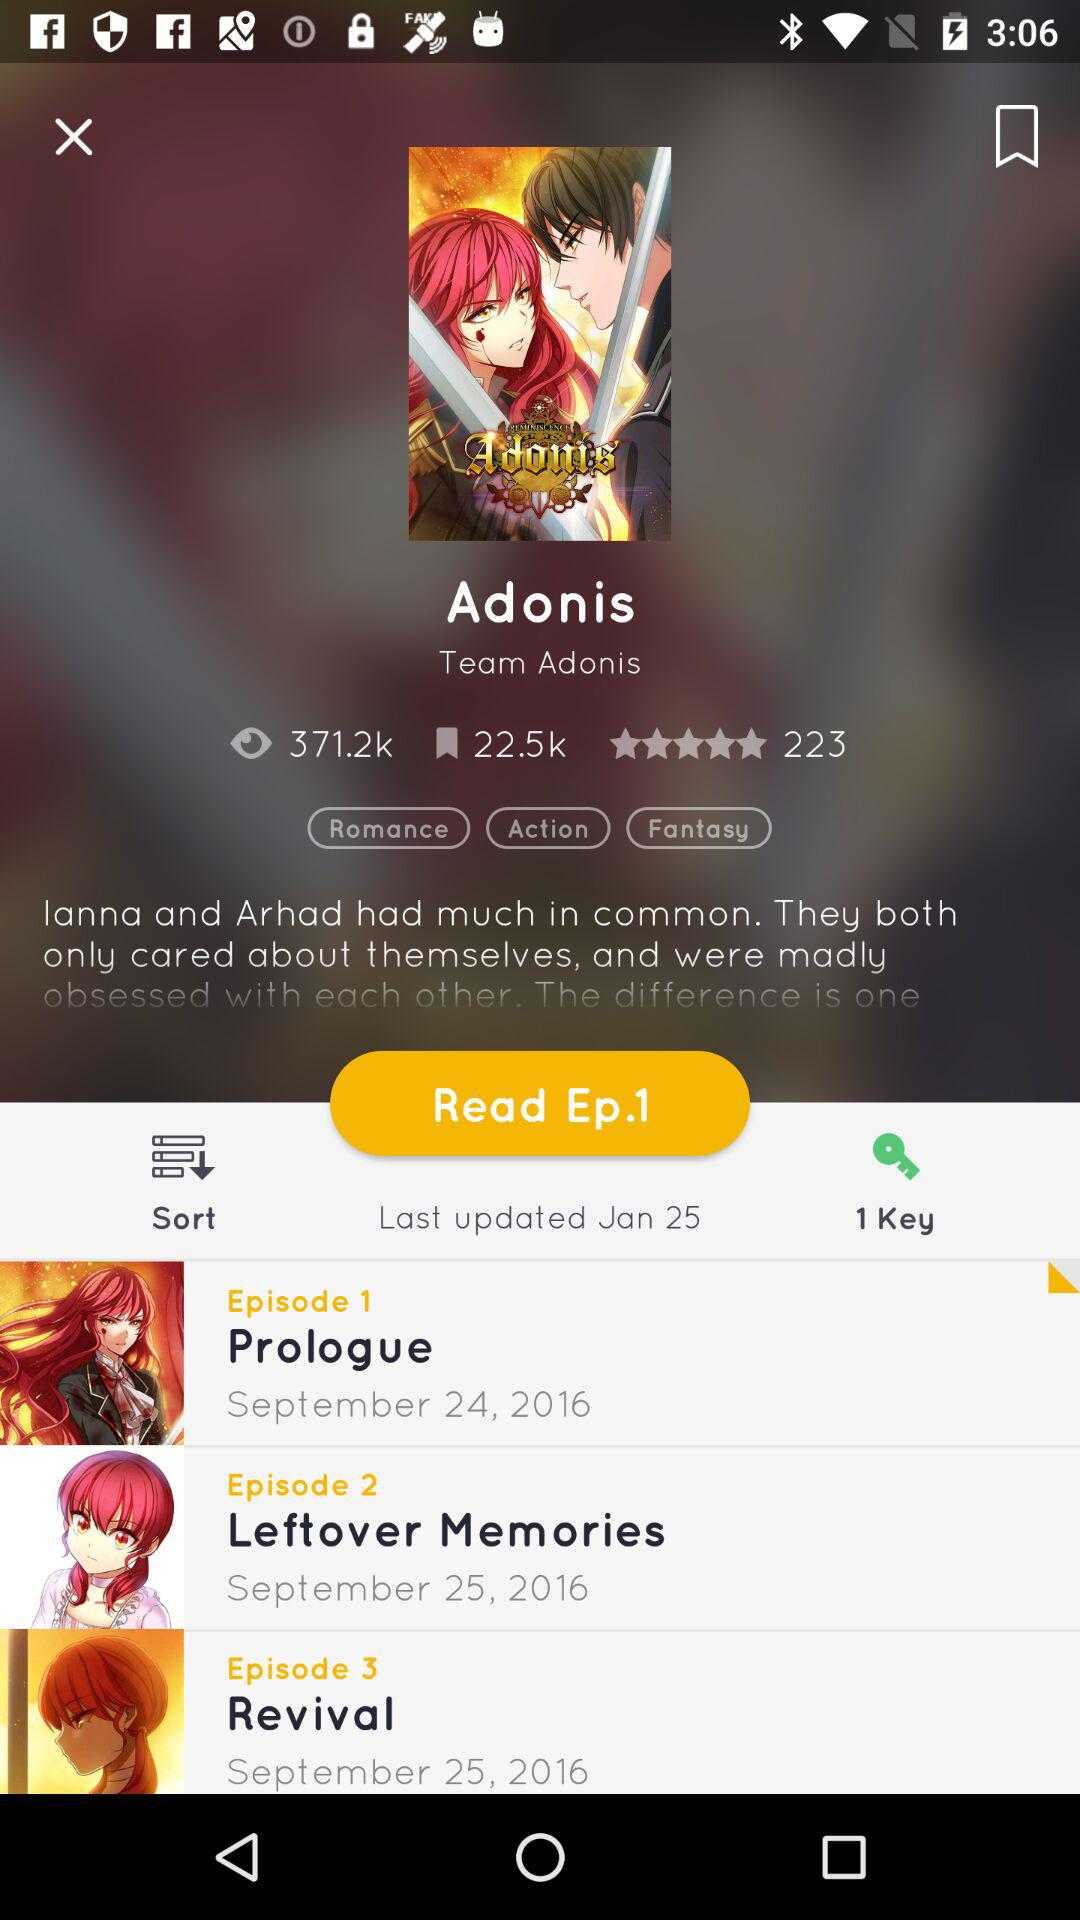What is the last updated date? The last updated date is January 25. 